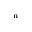Convert formula to latex. <formula><loc_0><loc_0><loc_500><loc_500>_ { n }</formula> 